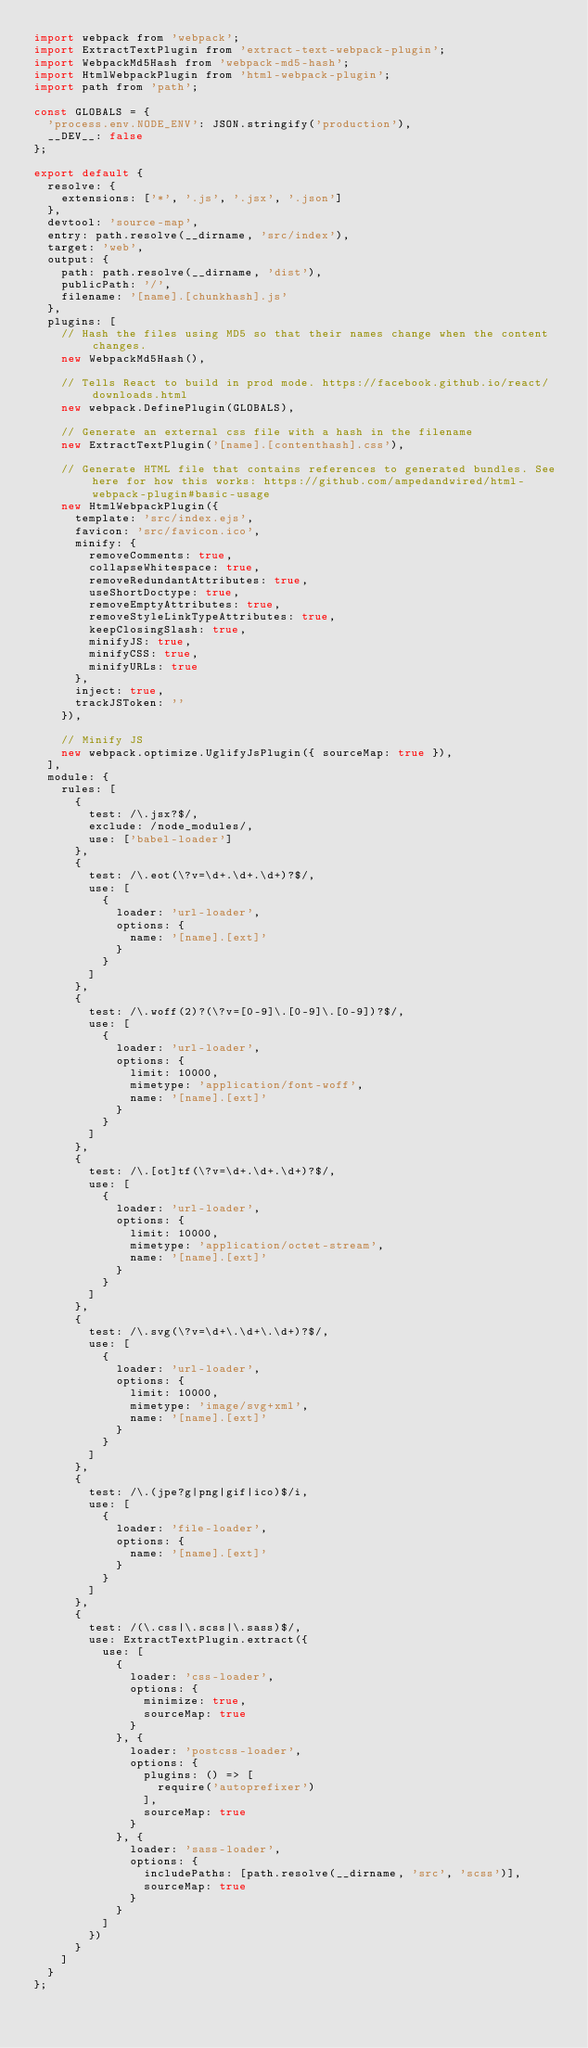<code> <loc_0><loc_0><loc_500><loc_500><_JavaScript_>import webpack from 'webpack';
import ExtractTextPlugin from 'extract-text-webpack-plugin';
import WebpackMd5Hash from 'webpack-md5-hash';
import HtmlWebpackPlugin from 'html-webpack-plugin';
import path from 'path';

const GLOBALS = {
  'process.env.NODE_ENV': JSON.stringify('production'),
  __DEV__: false
};

export default {
  resolve: {
    extensions: ['*', '.js', '.jsx', '.json']
  },
  devtool: 'source-map',
  entry: path.resolve(__dirname, 'src/index'),
  target: 'web',
  output: {
    path: path.resolve(__dirname, 'dist'),
    publicPath: '/',
    filename: '[name].[chunkhash].js'
  },
  plugins: [
    // Hash the files using MD5 so that their names change when the content changes.
    new WebpackMd5Hash(),

    // Tells React to build in prod mode. https://facebook.github.io/react/downloads.html
    new webpack.DefinePlugin(GLOBALS),

    // Generate an external css file with a hash in the filename
    new ExtractTextPlugin('[name].[contenthash].css'),

    // Generate HTML file that contains references to generated bundles. See here for how this works: https://github.com/ampedandwired/html-webpack-plugin#basic-usage
    new HtmlWebpackPlugin({
      template: 'src/index.ejs',
      favicon: 'src/favicon.ico',
      minify: {
        removeComments: true,
        collapseWhitespace: true,
        removeRedundantAttributes: true,
        useShortDoctype: true,
        removeEmptyAttributes: true,
        removeStyleLinkTypeAttributes: true,
        keepClosingSlash: true,
        minifyJS: true,
        minifyCSS: true,
        minifyURLs: true
      },
      inject: true,
      trackJSToken: ''
    }),

    // Minify JS
    new webpack.optimize.UglifyJsPlugin({ sourceMap: true }),
  ],
  module: {
    rules: [
      {
        test: /\.jsx?$/,
        exclude: /node_modules/,
        use: ['babel-loader']
      },
      {
        test: /\.eot(\?v=\d+.\d+.\d+)?$/,
        use: [
          {
            loader: 'url-loader',
            options: {
              name: '[name].[ext]'
            }
          }
        ]
      },
      {
        test: /\.woff(2)?(\?v=[0-9]\.[0-9]\.[0-9])?$/,
        use: [
          {
            loader: 'url-loader',
            options: {
              limit: 10000,
              mimetype: 'application/font-woff',
              name: '[name].[ext]'
            }
          }
        ]
      },
      {
        test: /\.[ot]tf(\?v=\d+.\d+.\d+)?$/,
        use: [
          {
            loader: 'url-loader',
            options: {
              limit: 10000,
              mimetype: 'application/octet-stream',
              name: '[name].[ext]'
            }
          }
        ]
      },
      {
        test: /\.svg(\?v=\d+\.\d+\.\d+)?$/,
        use: [
          {
            loader: 'url-loader',
            options: {
              limit: 10000,
              mimetype: 'image/svg+xml',
              name: '[name].[ext]'
            }
          }
        ]
      },
      {
        test: /\.(jpe?g|png|gif|ico)$/i,
        use: [
          {
            loader: 'file-loader',
            options: {
              name: '[name].[ext]'
            }
          }
        ]
      },
      {
        test: /(\.css|\.scss|\.sass)$/,
        use: ExtractTextPlugin.extract({
          use: [
            {
              loader: 'css-loader',
              options: {
                minimize: true,
                sourceMap: true
              }
            }, {
              loader: 'postcss-loader',
              options: {
                plugins: () => [
                  require('autoprefixer')
                ],
                sourceMap: true
              }
            }, {
              loader: 'sass-loader',
              options: {
                includePaths: [path.resolve(__dirname, 'src', 'scss')],
                sourceMap: true
              }
            }
          ]
        })
      }
    ]
  }
};
</code> 